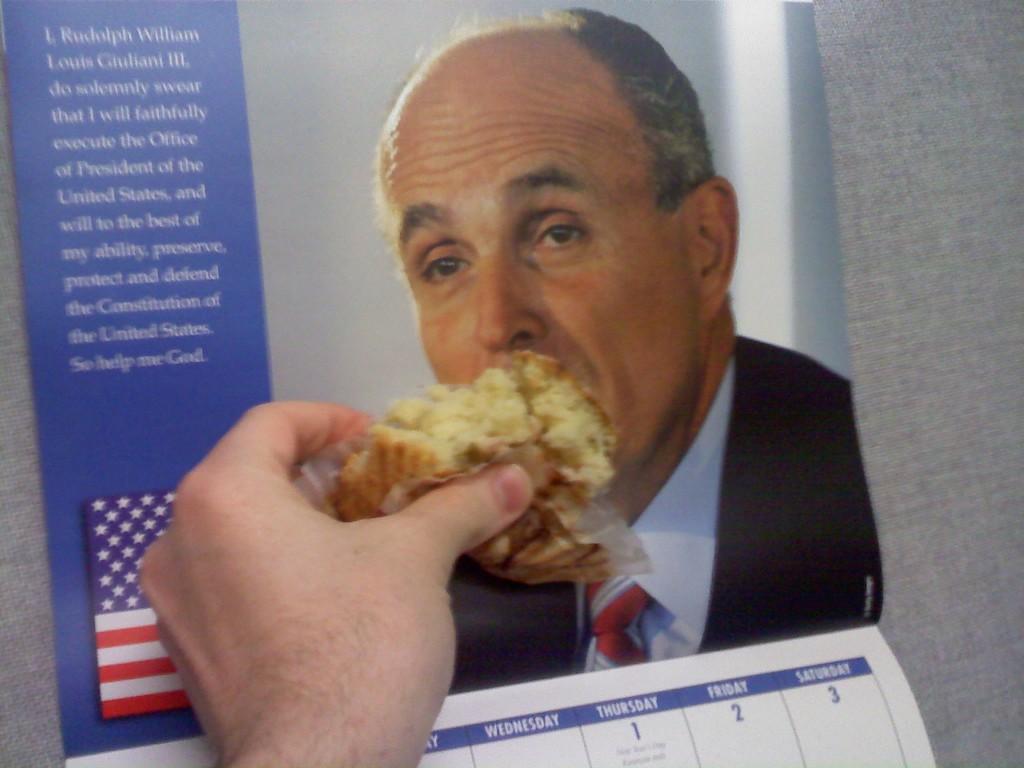What position does this calendar state rudy guiliani claim to be getting sworn in for?
Offer a very short reply. President. 